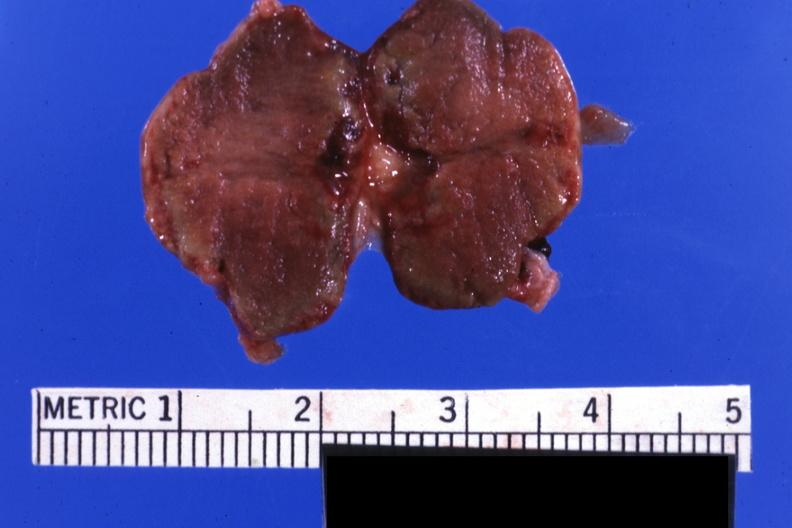where does this belong to?
Answer the question using a single word or phrase. Endocrine system 